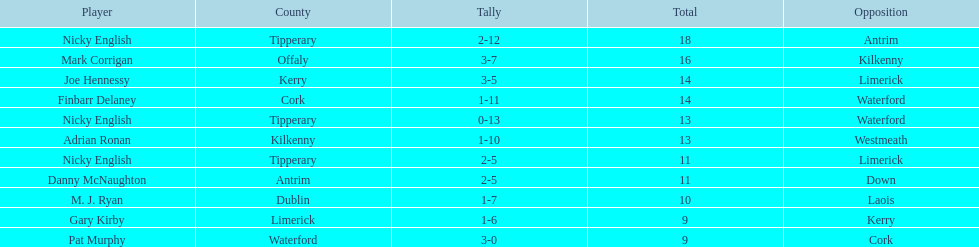Joe hennessy and finbarr delaney both scored how many points? 14. 